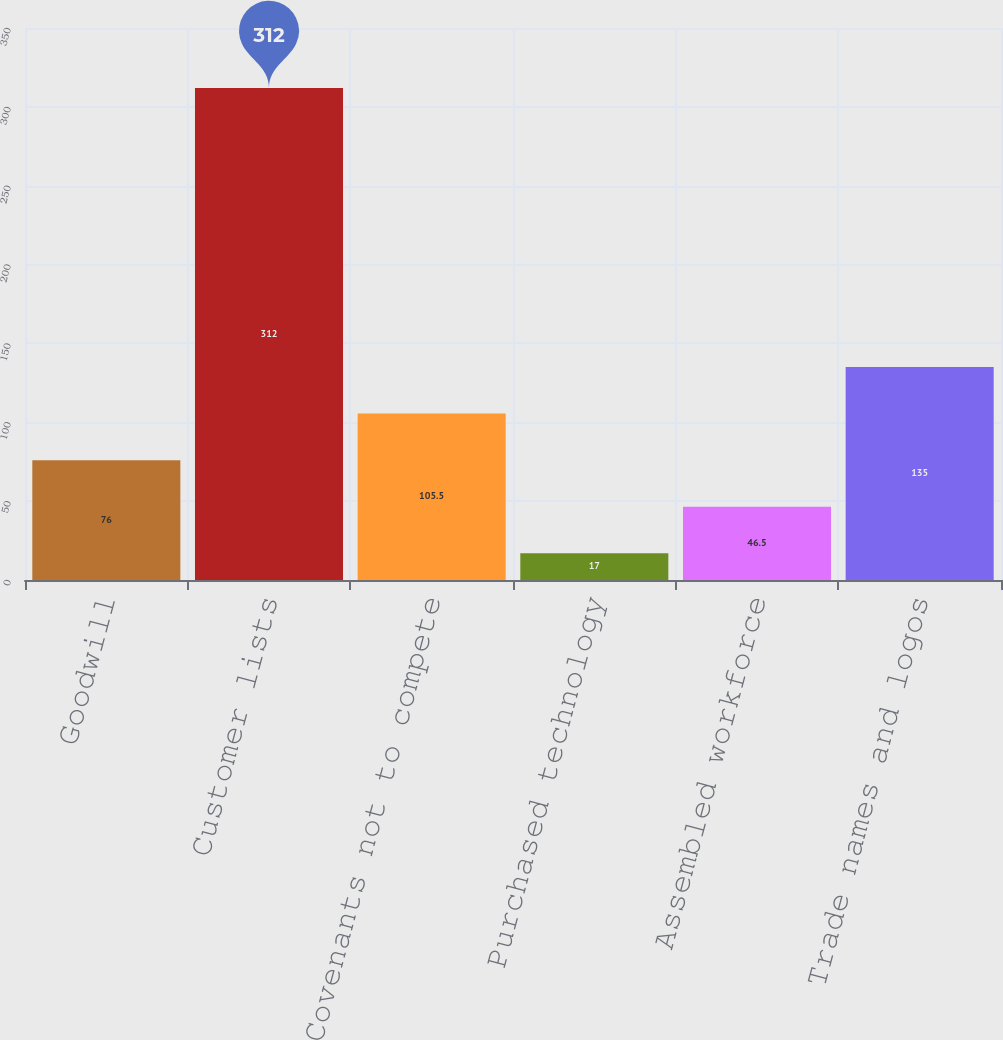<chart> <loc_0><loc_0><loc_500><loc_500><bar_chart><fcel>Goodwill<fcel>Customer lists<fcel>Covenants not to compete<fcel>Purchased technology<fcel>Assembled workforce<fcel>Trade names and logos<nl><fcel>76<fcel>312<fcel>105.5<fcel>17<fcel>46.5<fcel>135<nl></chart> 